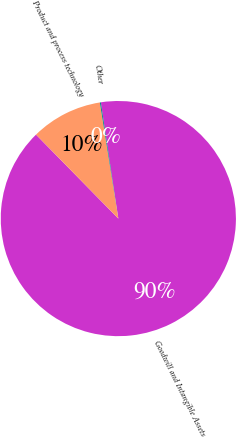Convert chart to OTSL. <chart><loc_0><loc_0><loc_500><loc_500><pie_chart><fcel>Goodwill and Intangible Assets<fcel>Product and process technology<fcel>Other<nl><fcel>90.04%<fcel>9.83%<fcel>0.13%<nl></chart> 